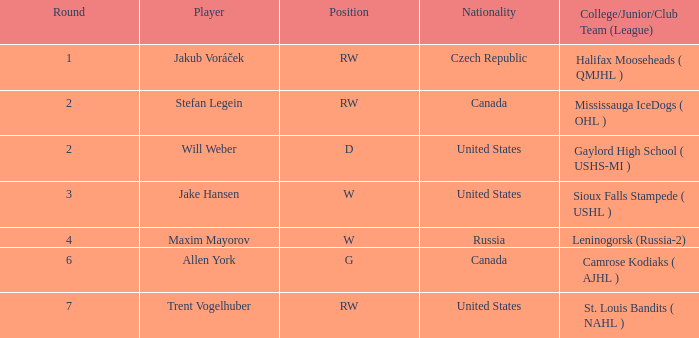Parse the full table. {'header': ['Round', 'Player', 'Position', 'Nationality', 'College/Junior/Club Team (League)'], 'rows': [['1', 'Jakub Voráček', 'RW', 'Czech Republic', 'Halifax Mooseheads ( QMJHL )'], ['2', 'Stefan Legein', 'RW', 'Canada', 'Mississauga IceDogs ( OHL )'], ['2', 'Will Weber', 'D', 'United States', 'Gaylord High School ( USHS-MI )'], ['3', 'Jake Hansen', 'W', 'United States', 'Sioux Falls Stampede ( USHL )'], ['4', 'Maxim Mayorov', 'W', 'Russia', 'Leninogorsk (Russia-2)'], ['6', 'Allen York', 'G', 'Canada', 'Camrose Kodiaks ( AJHL )'], ['7', 'Trent Vogelhuber', 'RW', 'United States', 'St. Louis Bandits ( NAHL )']]} What nationality was the round 6 draft pick? Canada. 